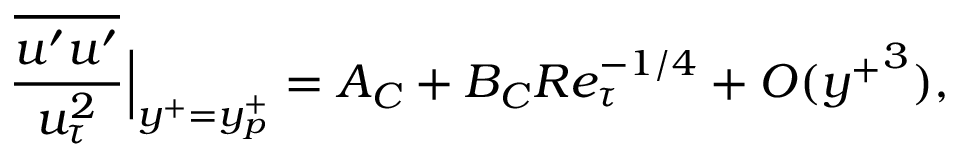Convert formula to latex. <formula><loc_0><loc_0><loc_500><loc_500>\frac { \overline { { u ^ { \prime } u ^ { \prime } } } } { u _ { \tau } ^ { 2 } } \Big | _ { y ^ { + } = y _ { p } ^ { + } } = A _ { C } + B _ { C } R e _ { \tau } ^ { - 1 / 4 } + O ( { y ^ { + } } ^ { 3 } ) ,</formula> 